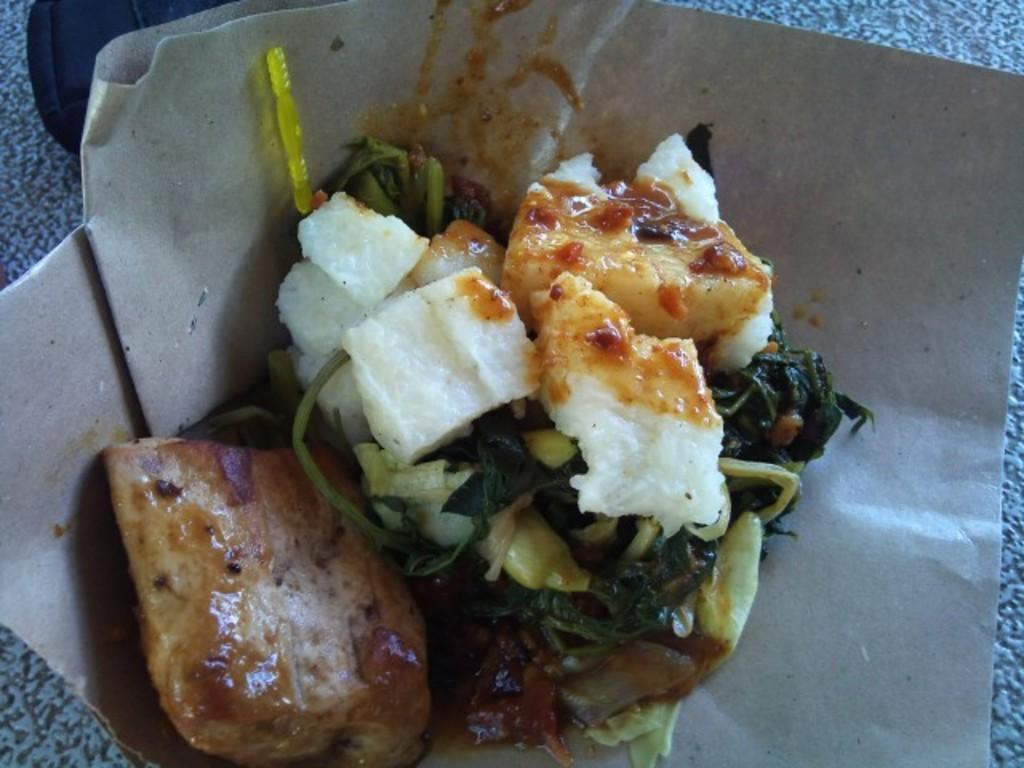Could you give a brief overview of what you see in this image? As we can see in the image there is paper and dish. 